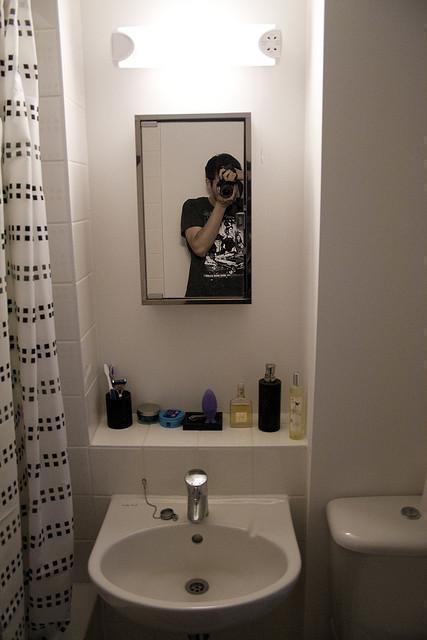A digital single lens reflex is normally known as?
Select the accurate response from the four choices given to answer the question.
Options: Dssl, dlrs, dssl, dslr. Dslr. 